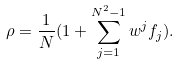<formula> <loc_0><loc_0><loc_500><loc_500>\rho = \frac { 1 } { N } ( 1 + \sum _ { j = 1 } ^ { N ^ { 2 } - 1 } w ^ { j } f _ { j } ) .</formula> 